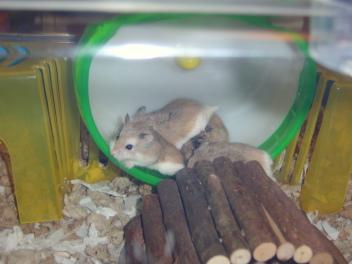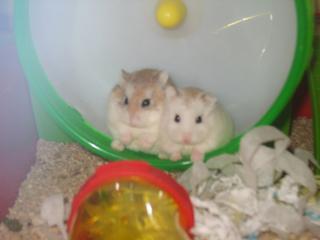The first image is the image on the left, the second image is the image on the right. Examine the images to the left and right. Is the description "in the right side image, there is a human hand holding the animal" accurate? Answer yes or no. No. The first image is the image on the left, the second image is the image on the right. For the images shown, is this caption "There is a gerbil being held by a single human hand in one of the images." true? Answer yes or no. No. 